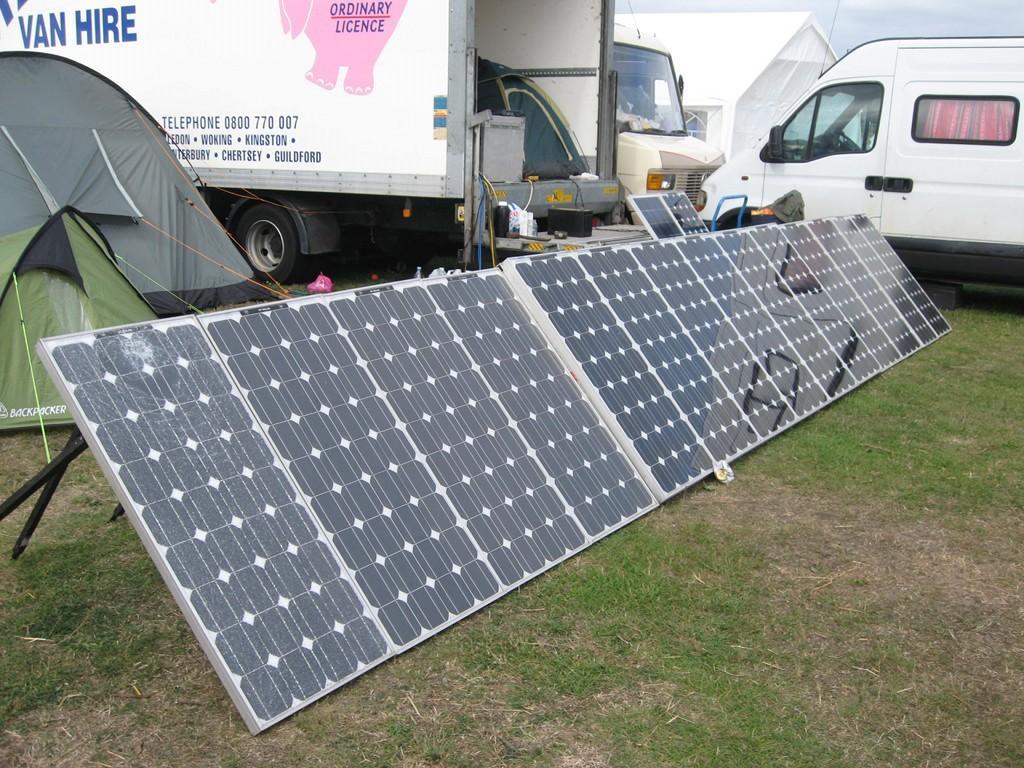How would you summarize this image in a sentence or two? In the foreground of this image, there are solar panels on the ground. Behind it, there are two vehicles, few objects and a tent. In the background, there is another vehicle, a white tent and the sky. 